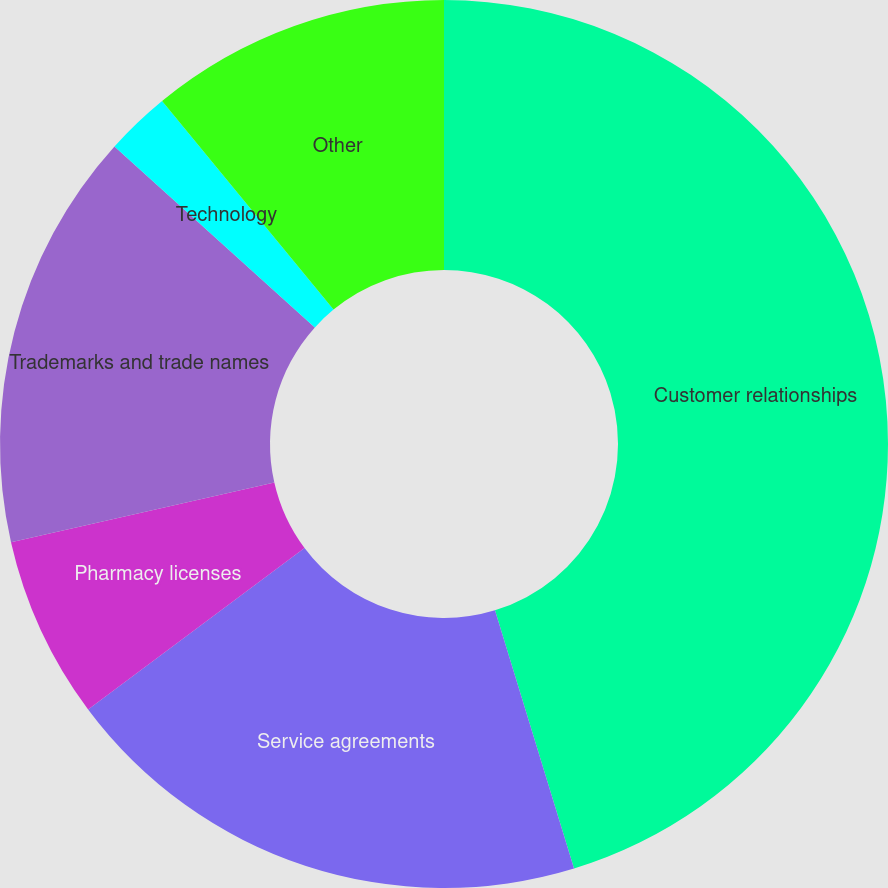Convert chart to OTSL. <chart><loc_0><loc_0><loc_500><loc_500><pie_chart><fcel>Customer relationships<fcel>Service agreements<fcel>Pharmacy licenses<fcel>Trademarks and trade names<fcel>Technology<fcel>Other<nl><fcel>45.27%<fcel>19.53%<fcel>6.65%<fcel>15.24%<fcel>2.36%<fcel>10.95%<nl></chart> 